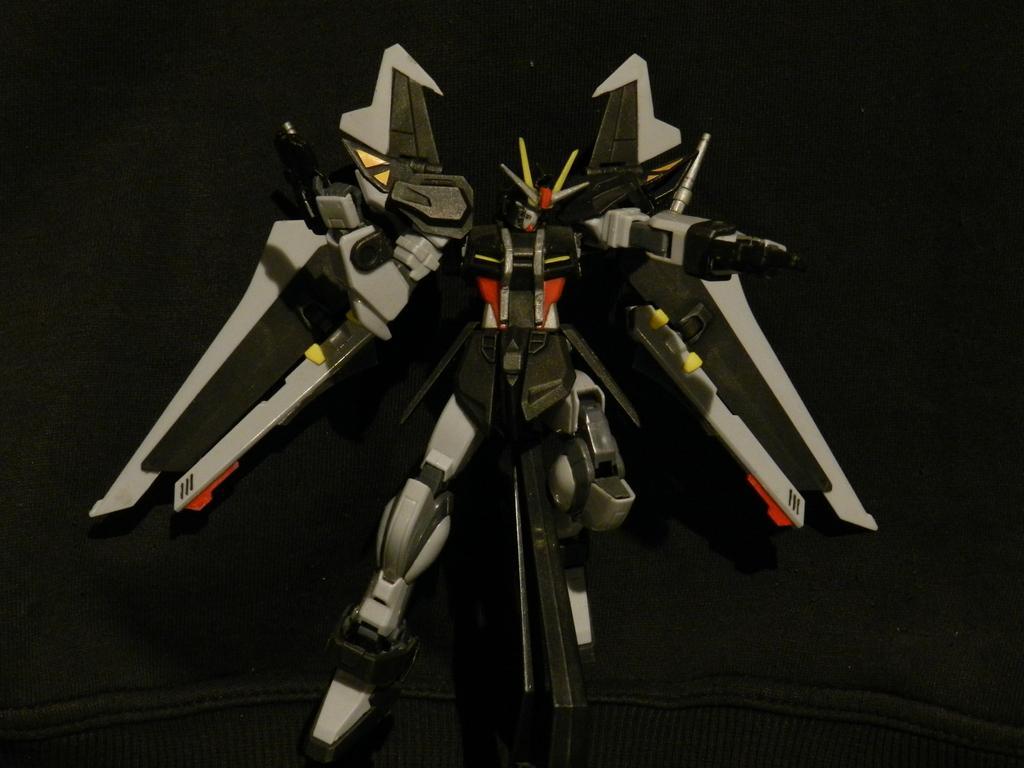Describe this image in one or two sentences. In this image I can see a robot. The background is dark in color. This image is taken may be in a hall. 